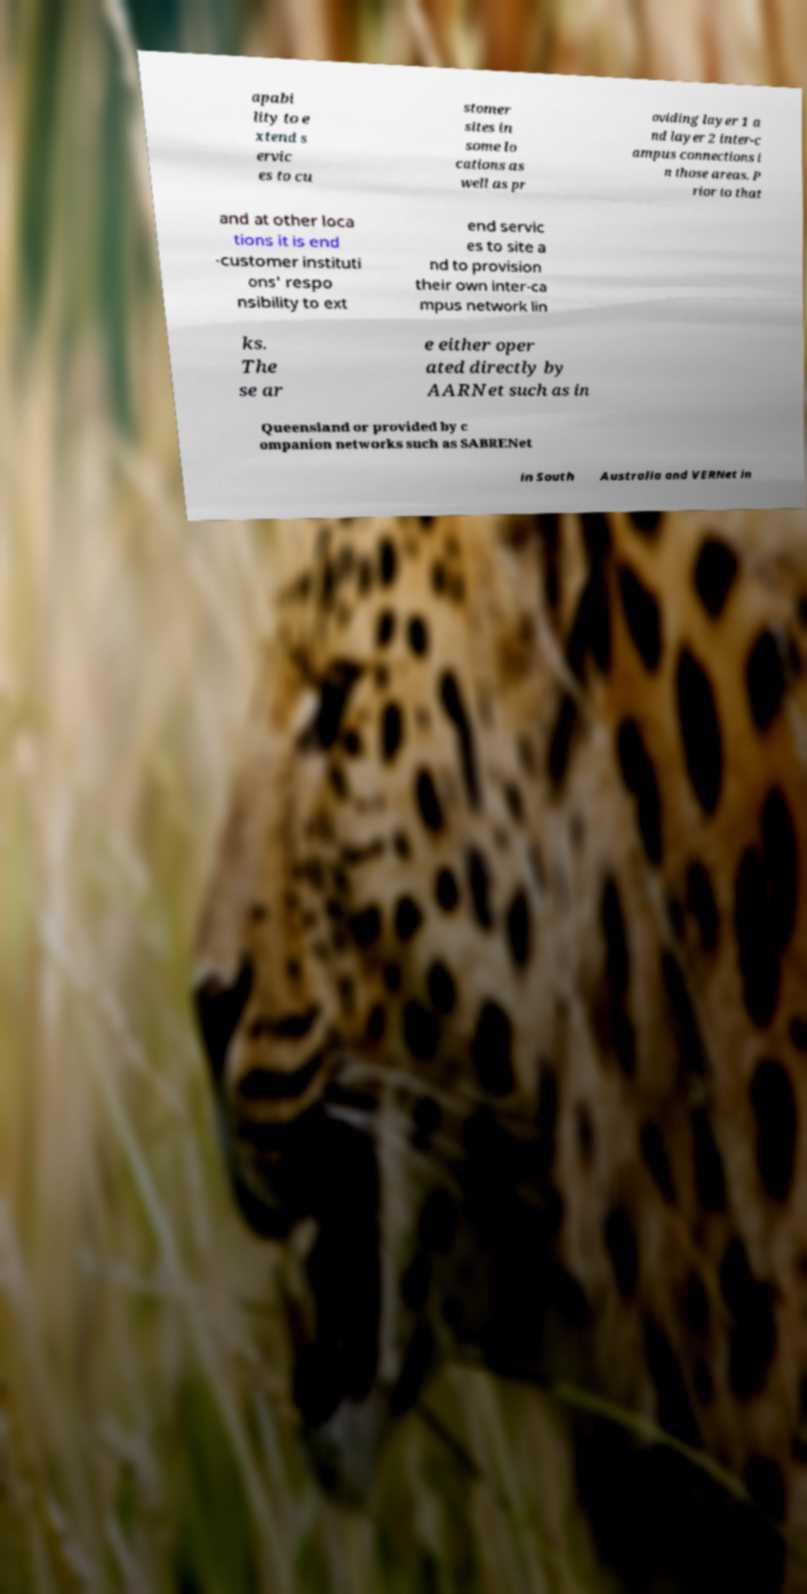Please read and relay the text visible in this image. What does it say? apabi lity to e xtend s ervic es to cu stomer sites in some lo cations as well as pr oviding layer 1 a nd layer 2 inter-c ampus connections i n those areas. P rior to that and at other loca tions it is end -customer instituti ons' respo nsibility to ext end servic es to site a nd to provision their own inter-ca mpus network lin ks. The se ar e either oper ated directly by AARNet such as in Queensland or provided by c ompanion networks such as SABRENet in South Australia and VERNet in 